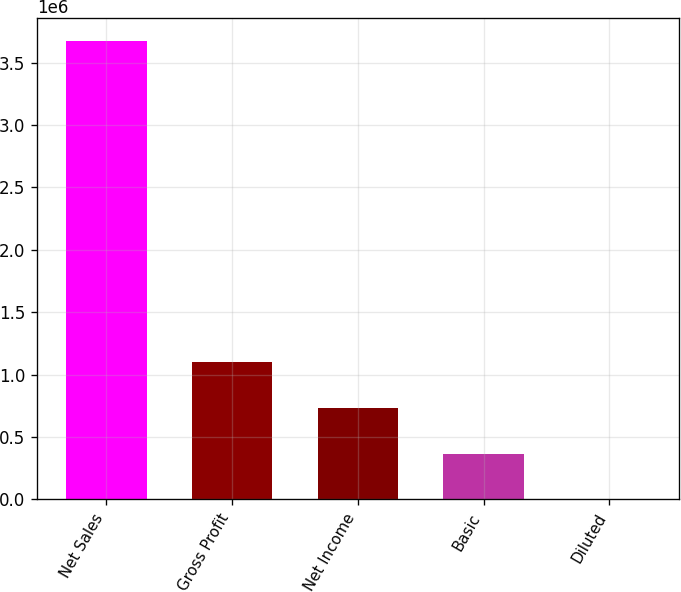<chart> <loc_0><loc_0><loc_500><loc_500><bar_chart><fcel>Net Sales<fcel>Gross Profit<fcel>Net Income<fcel>Basic<fcel>Diluted<nl><fcel>3.676e+06<fcel>1.10511e+06<fcel>735201<fcel>367601<fcel>1.39<nl></chart> 